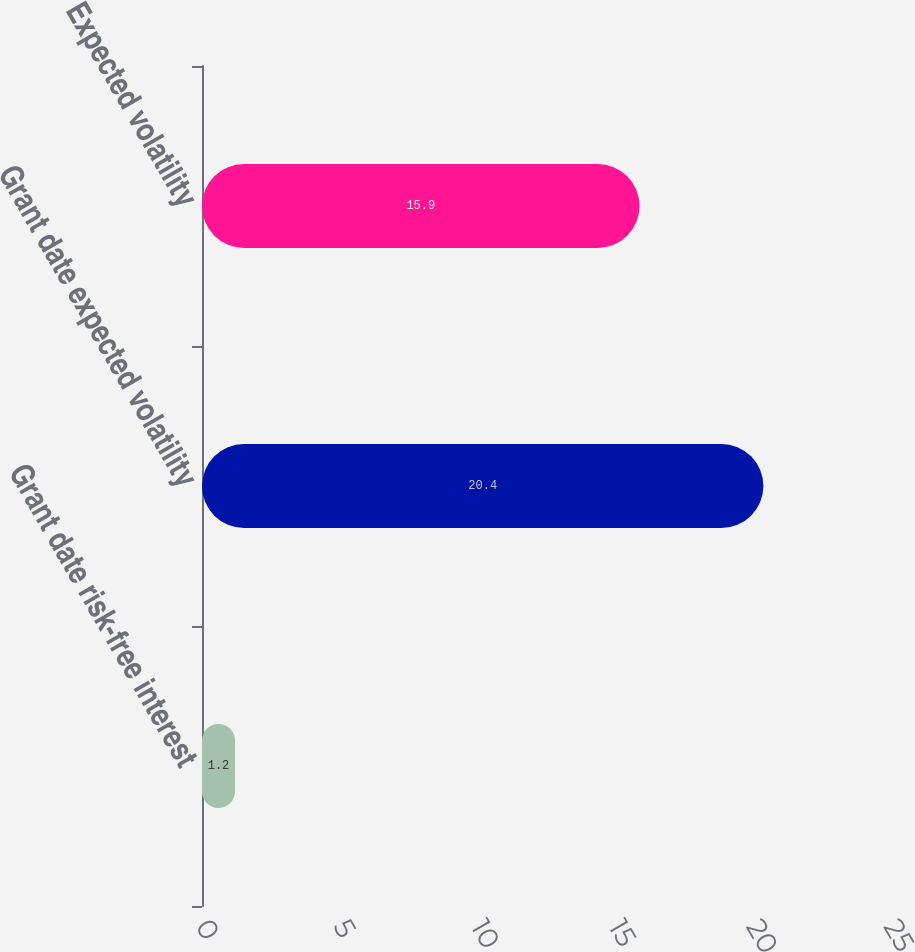Convert chart to OTSL. <chart><loc_0><loc_0><loc_500><loc_500><bar_chart><fcel>Grant date risk-free interest<fcel>Grant date expected volatility<fcel>Expected volatility<nl><fcel>1.2<fcel>20.4<fcel>15.9<nl></chart> 